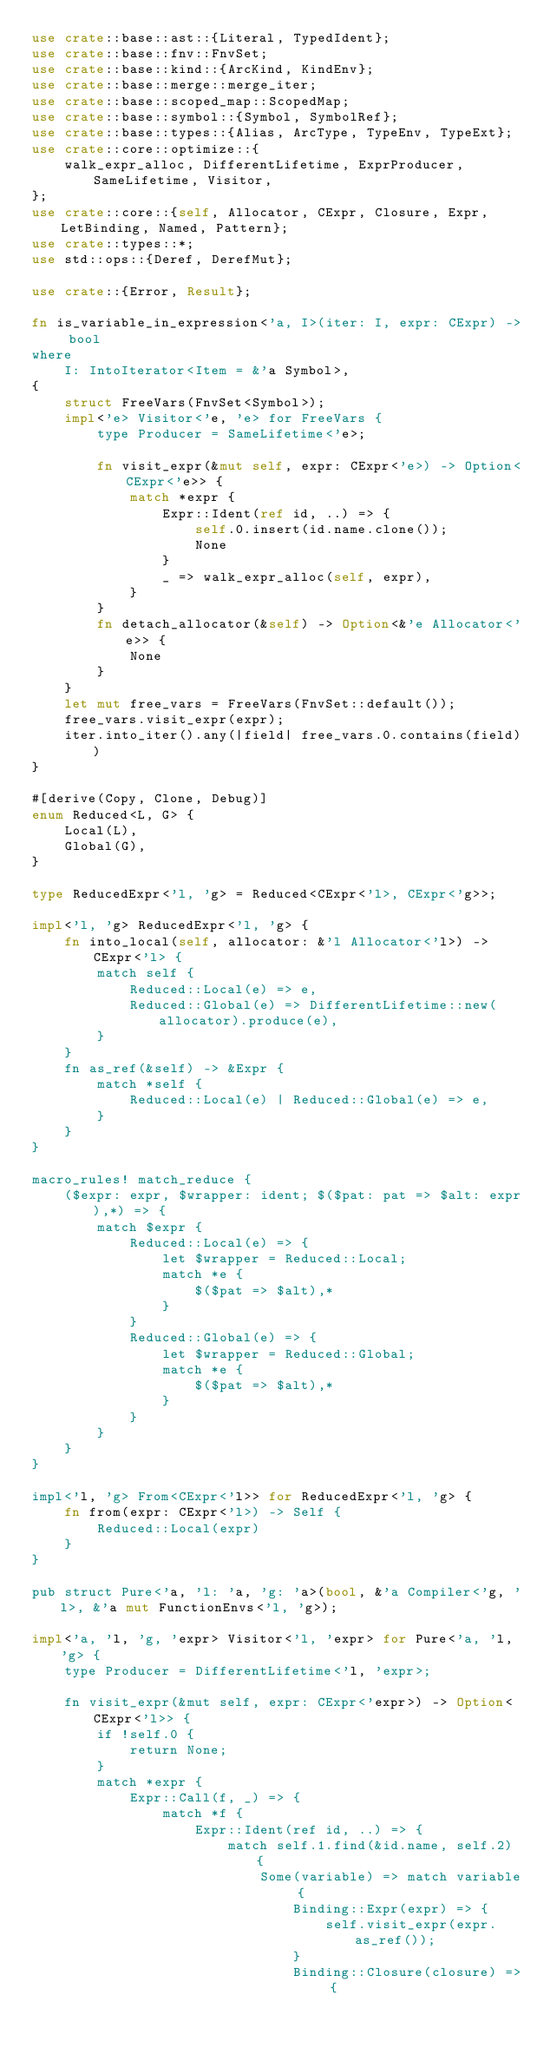<code> <loc_0><loc_0><loc_500><loc_500><_Rust_>use crate::base::ast::{Literal, TypedIdent};
use crate::base::fnv::FnvSet;
use crate::base::kind::{ArcKind, KindEnv};
use crate::base::merge::merge_iter;
use crate::base::scoped_map::ScopedMap;
use crate::base::symbol::{Symbol, SymbolRef};
use crate::base::types::{Alias, ArcType, TypeEnv, TypeExt};
use crate::core::optimize::{
    walk_expr_alloc, DifferentLifetime, ExprProducer, SameLifetime, Visitor,
};
use crate::core::{self, Allocator, CExpr, Closure, Expr, LetBinding, Named, Pattern};
use crate::types::*;
use std::ops::{Deref, DerefMut};

use crate::{Error, Result};

fn is_variable_in_expression<'a, I>(iter: I, expr: CExpr) -> bool
where
    I: IntoIterator<Item = &'a Symbol>,
{
    struct FreeVars(FnvSet<Symbol>);
    impl<'e> Visitor<'e, 'e> for FreeVars {
        type Producer = SameLifetime<'e>;

        fn visit_expr(&mut self, expr: CExpr<'e>) -> Option<CExpr<'e>> {
            match *expr {
                Expr::Ident(ref id, ..) => {
                    self.0.insert(id.name.clone());
                    None
                }
                _ => walk_expr_alloc(self, expr),
            }
        }
        fn detach_allocator(&self) -> Option<&'e Allocator<'e>> {
            None
        }
    }
    let mut free_vars = FreeVars(FnvSet::default());
    free_vars.visit_expr(expr);
    iter.into_iter().any(|field| free_vars.0.contains(field))
}

#[derive(Copy, Clone, Debug)]
enum Reduced<L, G> {
    Local(L),
    Global(G),
}

type ReducedExpr<'l, 'g> = Reduced<CExpr<'l>, CExpr<'g>>;

impl<'l, 'g> ReducedExpr<'l, 'g> {
    fn into_local(self, allocator: &'l Allocator<'l>) -> CExpr<'l> {
        match self {
            Reduced::Local(e) => e,
            Reduced::Global(e) => DifferentLifetime::new(allocator).produce(e),
        }
    }
    fn as_ref(&self) -> &Expr {
        match *self {
            Reduced::Local(e) | Reduced::Global(e) => e,
        }
    }
}

macro_rules! match_reduce {
    ($expr: expr, $wrapper: ident; $($pat: pat => $alt: expr),*) => {
        match $expr {
            Reduced::Local(e) => {
                let $wrapper = Reduced::Local;
                match *e {
                    $($pat => $alt),*
                }
            }
            Reduced::Global(e) => {
                let $wrapper = Reduced::Global;
                match *e {
                    $($pat => $alt),*
                }
            }
        }
    }
}

impl<'l, 'g> From<CExpr<'l>> for ReducedExpr<'l, 'g> {
    fn from(expr: CExpr<'l>) -> Self {
        Reduced::Local(expr)
    }
}

pub struct Pure<'a, 'l: 'a, 'g: 'a>(bool, &'a Compiler<'g, 'l>, &'a mut FunctionEnvs<'l, 'g>);

impl<'a, 'l, 'g, 'expr> Visitor<'l, 'expr> for Pure<'a, 'l, 'g> {
    type Producer = DifferentLifetime<'l, 'expr>;

    fn visit_expr(&mut self, expr: CExpr<'expr>) -> Option<CExpr<'l>> {
        if !self.0 {
            return None;
        }
        match *expr {
            Expr::Call(f, _) => {
                match *f {
                    Expr::Ident(ref id, ..) => {
                        match self.1.find(&id.name, self.2) {
                            Some(variable) => match variable {
                                Binding::Expr(expr) => {
                                    self.visit_expr(expr.as_ref());
                                }
                                Binding::Closure(closure) => {</code> 